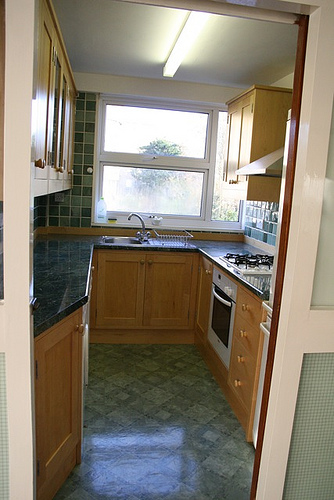Can you describe the most charming aspect of this kitchen? The most charming aspect of this kitchen is the quaint window above the sink. It allows natural light to flood the space, making the room feel open and inviting. With the view of the greenery outside, washing dishes here could be a calming and picturesque experience. 